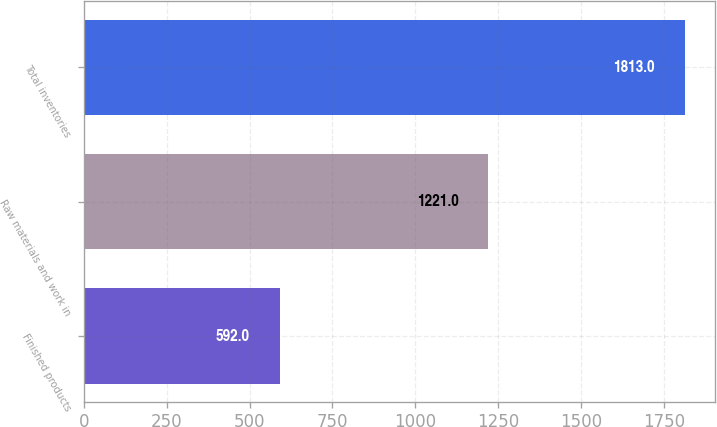Convert chart to OTSL. <chart><loc_0><loc_0><loc_500><loc_500><bar_chart><fcel>Finished products<fcel>Raw materials and work in<fcel>Total inventories<nl><fcel>592<fcel>1221<fcel>1813<nl></chart> 